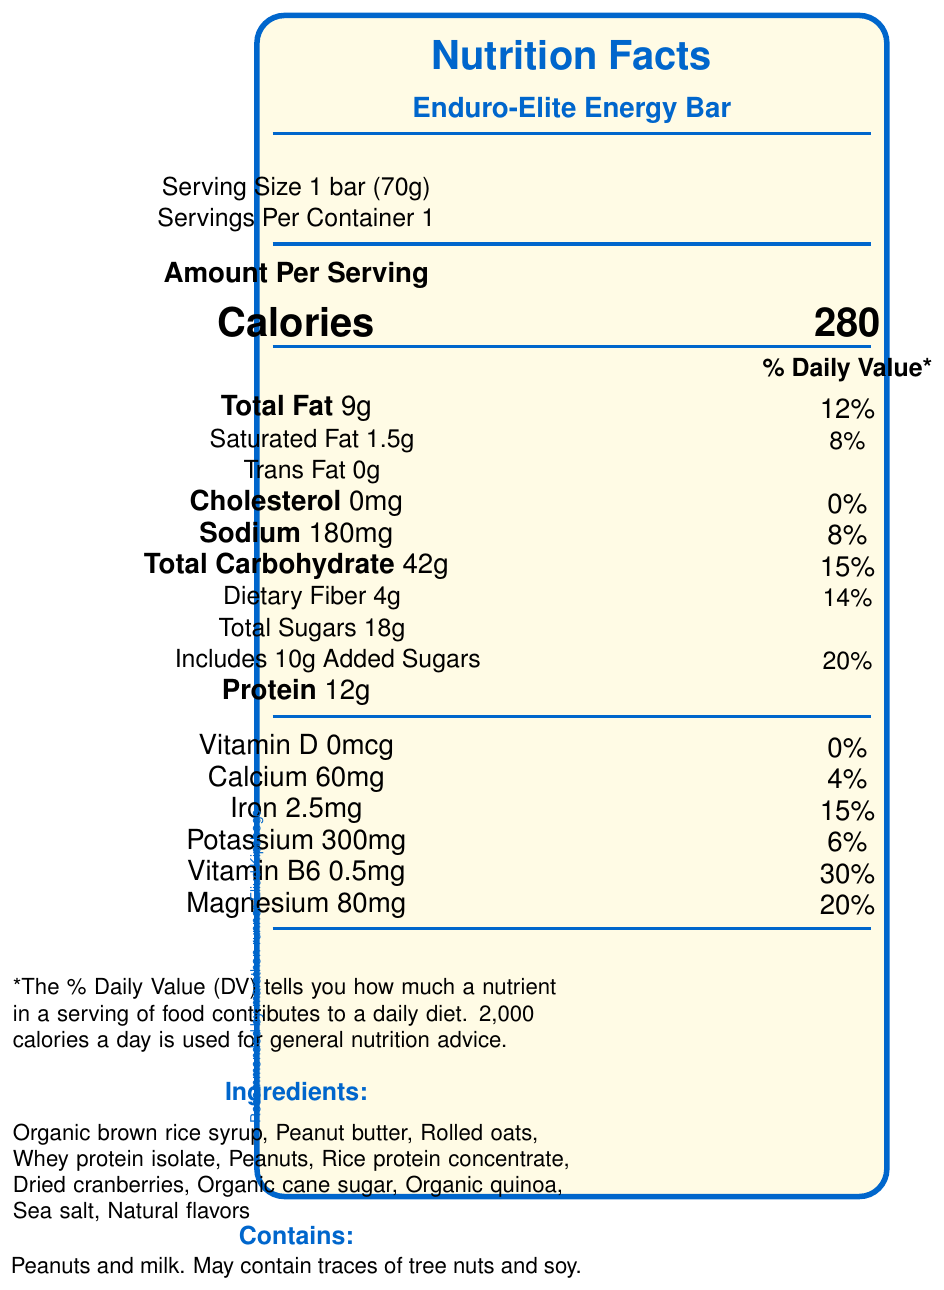what is the serving size of the Enduro-Elite Energy Bar? The document lists the serving size as "1 bar (70g)".
Answer: 1 bar (70g) how many calories are in one serving of the Enduro-Elite Energy Bar? The "Calories" value next to the measurement is given as 280.
Answer: 280 calories what percentage of the daily value of saturated fat does one serving of the Enduro-Elite Energy Bar provide? The document states "Saturated Fat 1.5g", with a daily value of 8%.
Answer: 8% how much protein does the Enduro-Elite Energy Bar contain? The nutrition facts indicate "Protein 12g".
Answer: 12g list three main ingredients in the Enduro-Elite Energy Bar The ingredients list starts with "Organic brown rice syrup", "Peanut butter", and "Rolled oats".
Answer: Organic brown rice syrup, Peanut butter, Rolled oats which macronutrient is highest in the Enduro-Elite Energy Bar? A. Protein B. Total Fat C. Total Carbohydrate D. Dietary Fiber The total carbohydrates are 42g, which is higher than both protein (12g) and total fat (9g).
Answer: C. Total Carbohydrate how much iron is in one serving of the Enduro-Elite Energy Bar? A. 1mg B. 2.5mg C. 3mg D. 1.5mg The document shows that iron is listed at 2.5mg.
Answer: B. 2.5mg is the Enduro-Elite Energy Bar gluten-free? The document includes the label "Gluten-Free" under certified claims.
Answer: Yes can you eat this bar if you have a peanut allergy? The allergen information section states that the bar contains peanuts.
Answer: No what is the purpose of the added electrolytes in the Enduro-Elite Energy Bar? The document mentions "Added electrolytes for improved hydration" under performance benefits.
Answer: Improved hydration what certification claims does the Enduro-Elite Energy Bar have? The document lists three certified claims: "Non-GMO Project Verified", "Gluten-Free", and "Low Glycemic Index".
Answer: Non-GMO Project Verified, Gluten-Free, Low Glycemic Index how many grams of added sugars are included in one serving? The label shows "Includes 10g Added Sugars".
Answer: 10g what are the benefits of the Enduro-Elite Energy Bar for endurance athletes? The performance benefits section lists these four benefits.
Answer: Balanced macronutrient profile for sustained energy, Added electrolytes for improved hydration, High in complex carbohydrates for endurance, Contains BCAAs for muscle recovery does the Enduro-Elite Energy Bar contain any tree nuts? The allergen information states "May contain traces of tree nuts".
Answer: May contain traces of tree nuts who recommends the Enduro-Elite Energy Bar for long-distance training? The athlete endorsement section mentions Eliud Kipchoge.
Answer: Marathon runner Eliud Kipchoge what percentage of the daily value of vitamin B6 does the Enduro-Elite Energy Bar provide? The document lists "Vitamin B6 0.5mg" with a daily value of 30%.
Answer: 30% what are the main ideas conveyed in this document? The document is a comprehensive summary of the Enduro-Elite Energy Bar's nutrition facts, ingredients, allergen info, endorsements, and certifications, all aimed at conveying the product's benefits for endurance athletes.
Answer: The document provides detailed nutritional information about the Enduro-Elite Energy Bar, including ingredients, allergen information, certified claims, and performance benefits specifically designed for endurance athletes. how is the Enduro-Elite Energy Bar developed to optimize performance? The document states "Developed using performance data from elite endurance athletes to optimize energy release and nutrient absorption" but does not provide detailed methods or data sources.
Answer: Not enough information 